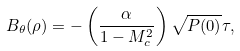<formula> <loc_0><loc_0><loc_500><loc_500>B _ { \theta } ( \rho ) = - \left ( \frac { \alpha } { 1 - M _ { c } ^ { 2 } } \right ) \sqrt { P ( 0 ) } \tau ,</formula> 